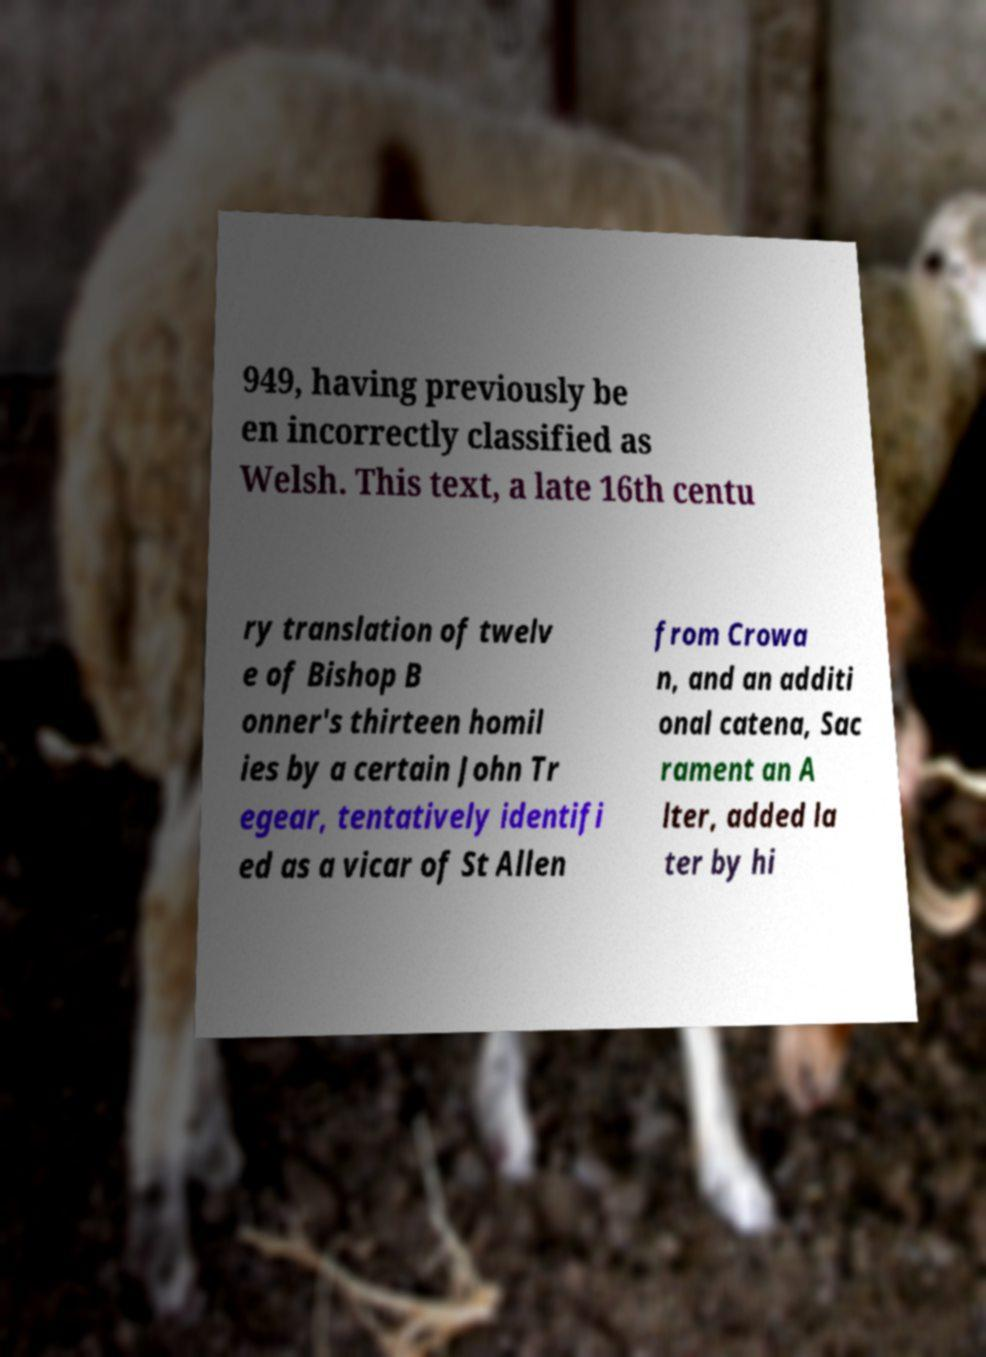For documentation purposes, I need the text within this image transcribed. Could you provide that? 949, having previously be en incorrectly classified as Welsh. This text, a late 16th centu ry translation of twelv e of Bishop B onner's thirteen homil ies by a certain John Tr egear, tentatively identifi ed as a vicar of St Allen from Crowa n, and an additi onal catena, Sac rament an A lter, added la ter by hi 